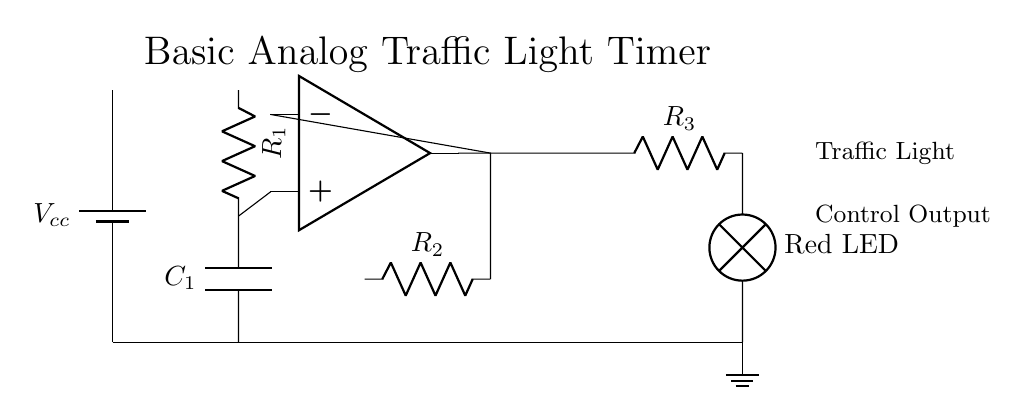What is the power supply voltage? The power supply voltage is indicated next to the battery symbol in the circuit diagram. It is labeled as Vcc without a specific value provided, but typically, it is a standard voltage.
Answer: Vcc What components are present in the timing circuit? The timing circuit consists of a resistor labeled R1 and a capacitor labeled C1. You can identify these components from their symbols and labels in the diagram.
Answer: R1 and C1 How many resistors are in the circuit? By counting the resistor symbols in the diagram, we find three resistors labeled R1, R2, and R3. This total gives us the number of resistors present.
Answer: Three What is the output state of the circuit? The output state can be determined by the connection leading from the op-amp output to the Red LED. The circuit design implies that the LED will illuminate when the op-amp output is high, making it a simple binary output state.
Answer: Red LED What is the role of R2 in the circuit? Resistor R2 is part of the feedback network of the op-amp. It helps to set the gain and stability of the comparator stage, which affects how the timing is managed. This is inferred from its connection to the inverting input of the op-amp.
Answer: Feedback component How does the timing circuit affect the traffic light? The timing circuit, formed by R1 and C1, controls how quickly the input to the comparator changes, influencing the switching time for the output signal that controls the traffic light. The time constant is determined by the resistor-capacitor combination.
Answer: Timing control 